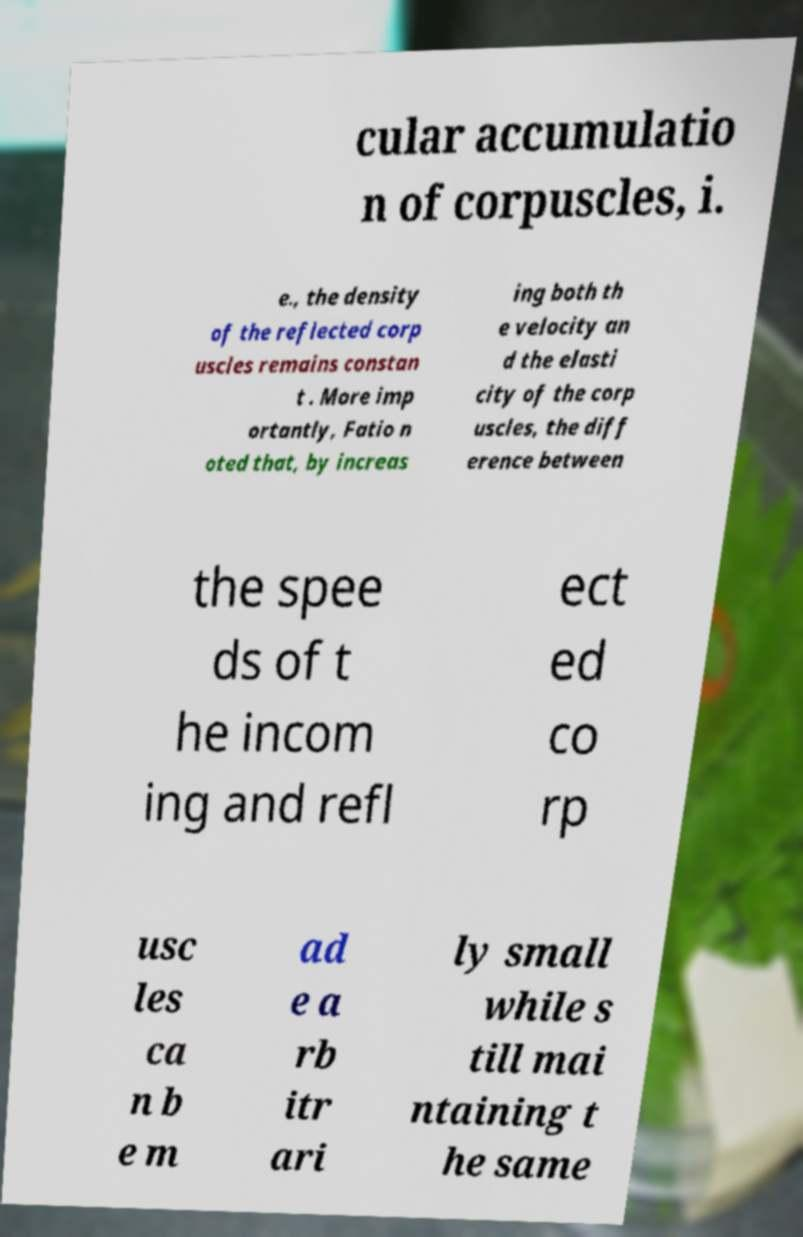Please read and relay the text visible in this image. What does it say? cular accumulatio n of corpuscles, i. e., the density of the reflected corp uscles remains constan t . More imp ortantly, Fatio n oted that, by increas ing both th e velocity an d the elasti city of the corp uscles, the diff erence between the spee ds of t he incom ing and refl ect ed co rp usc les ca n b e m ad e a rb itr ari ly small while s till mai ntaining t he same 